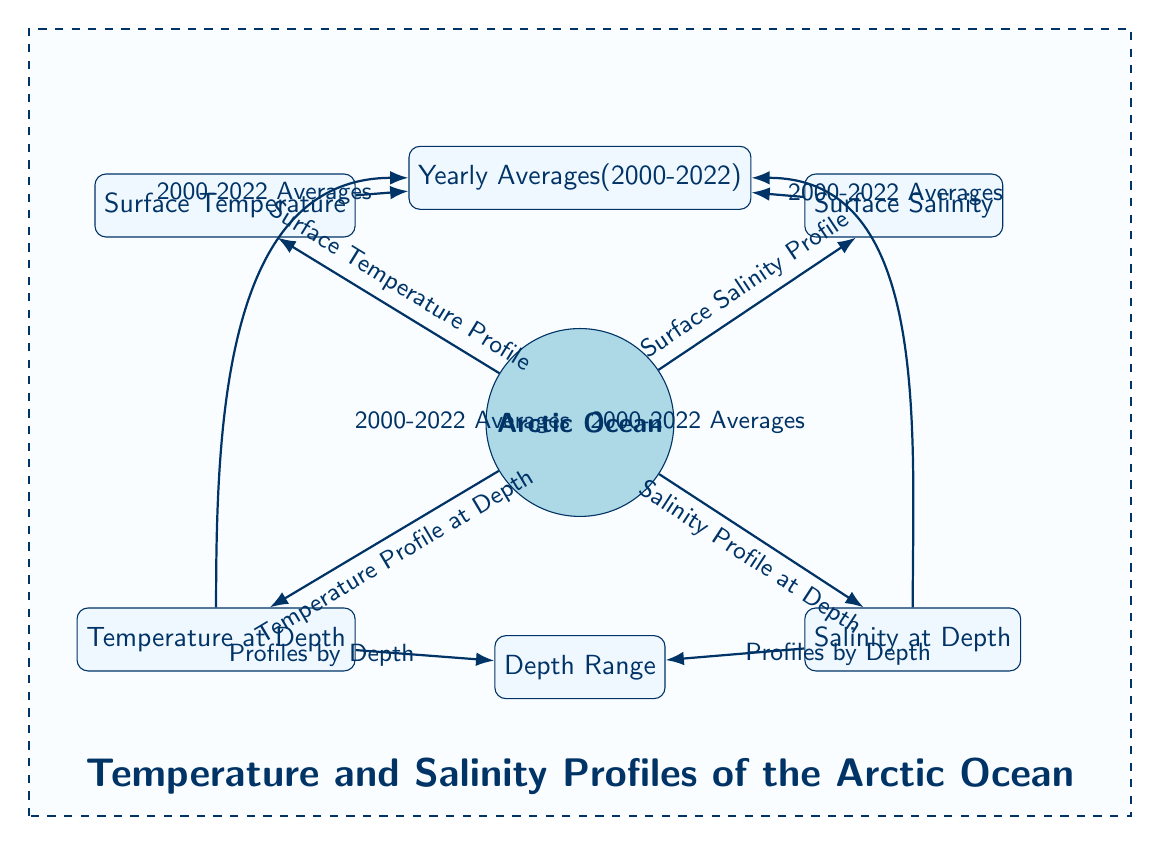What is the main focus of the diagram? The diagram is centered around profiling temperature and salinity in the Arctic Ocean, indicating it primarily explores these two parameters over the specified timeframe.
Answer: Temperature and Salinity Profiles How many average years does the data cover? The diagram explicitly states that the averages are taken over a span from 2000 to 2022, which accounts for a total of 23 years.
Answer: 23 years What type of profiles are shown for the parameters? The diagram illustrates both surface and depth profiles for temperature and salinity, signifying that it analyzes these parameters at different oceanic depths and surface levels.
Answer: Surface and Depth Profiles Which node is connected to "Yearly Averages"? The surface temperature node connects with "Yearly Averages," demonstrating the relationship where the surface temperature profile is averaged over the years from 2000 to 2022.
Answer: Surface Temperature How are the temperature and salinity profiles at depth represented in the diagram? The diagram has directed edges connecting temperature and salinity profiles at depth to the "Profiles by Depth" node, suggesting that these parameters are measured and illustrated as functions of depth.
Answer: By Depth What color theme is used to represent the Arctic Ocean? The Arctic Ocean node is illustrated using a distinctive shade of blue (arctic blue), which differentiates it visually from other elements in the diagram.
Answer: Arctic Blue Is there a separate representation for yearly averages at depth? Yes, the diagram indicates that both temperature and salinity data at depth include yearly averages within the overall analysis conducted from 2000 to 2022.
Answer: Yes What element is positioned below the "Arctic Ocean" node? The "Temperature at Depth" node is positioned directly below the Arctic Ocean node, indicating its hierarchical relation within the temperature profile section of the diagram.
Answer: Temperature at Depth Which two nodes show the relationship of "Profiles by Depth"? The nodes "Temperature at Depth" and "Salinity at Depth" both link to "Profiles by Depth," stressing their shared relationship in the context of the diagram's analysis of depth-related data.
Answer: Temperature and Salinity at Depth 